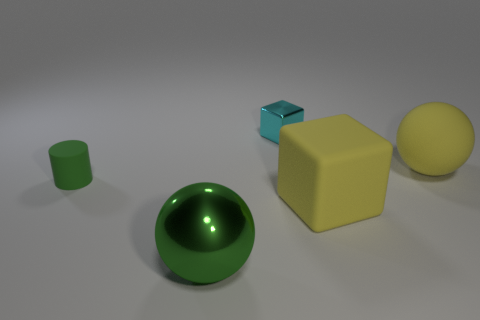Add 1 purple cylinders. How many objects exist? 6 Subtract all cubes. How many objects are left? 3 Subtract all tiny rubber objects. Subtract all yellow rubber objects. How many objects are left? 2 Add 3 tiny green cylinders. How many tiny green cylinders are left? 4 Add 4 small green rubber cylinders. How many small green rubber cylinders exist? 5 Subtract 0 gray blocks. How many objects are left? 5 